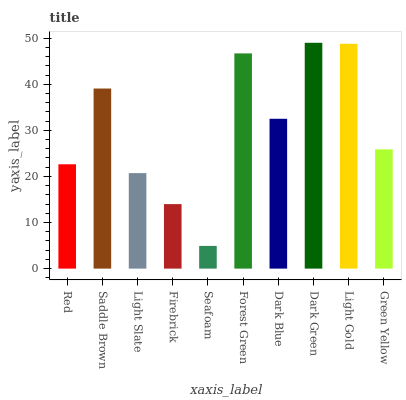Is Seafoam the minimum?
Answer yes or no. Yes. Is Dark Green the maximum?
Answer yes or no. Yes. Is Saddle Brown the minimum?
Answer yes or no. No. Is Saddle Brown the maximum?
Answer yes or no. No. Is Saddle Brown greater than Red?
Answer yes or no. Yes. Is Red less than Saddle Brown?
Answer yes or no. Yes. Is Red greater than Saddle Brown?
Answer yes or no. No. Is Saddle Brown less than Red?
Answer yes or no. No. Is Dark Blue the high median?
Answer yes or no. Yes. Is Green Yellow the low median?
Answer yes or no. Yes. Is Red the high median?
Answer yes or no. No. Is Red the low median?
Answer yes or no. No. 